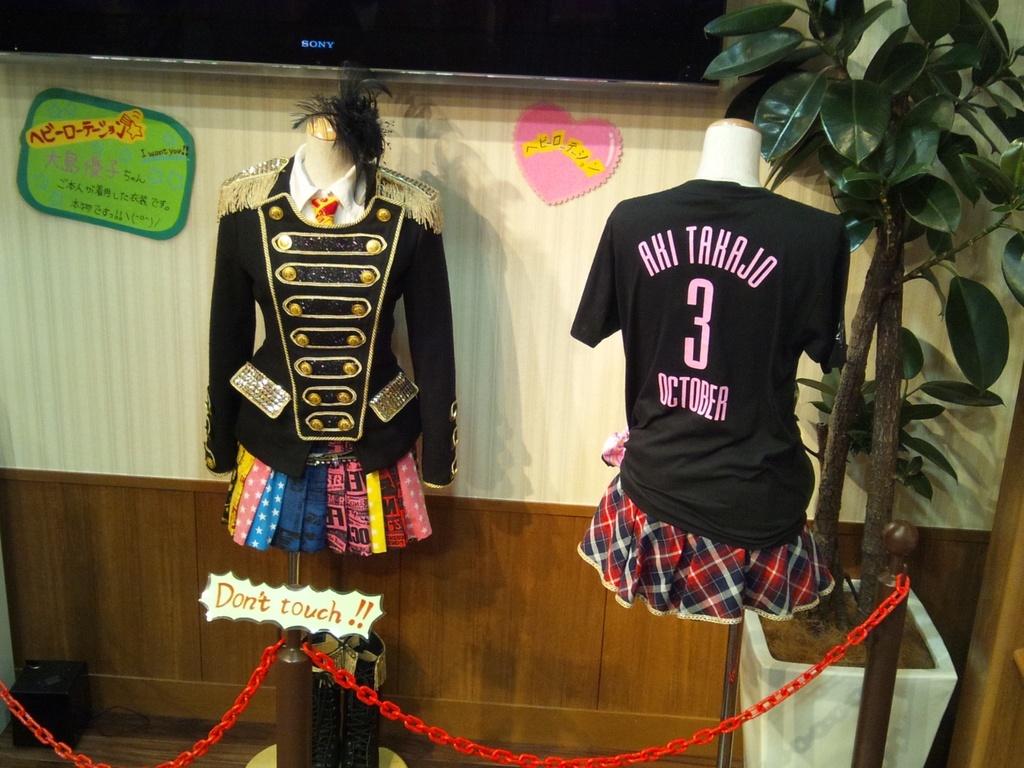What's the month the shirt was made for?
Your answer should be compact. October. 